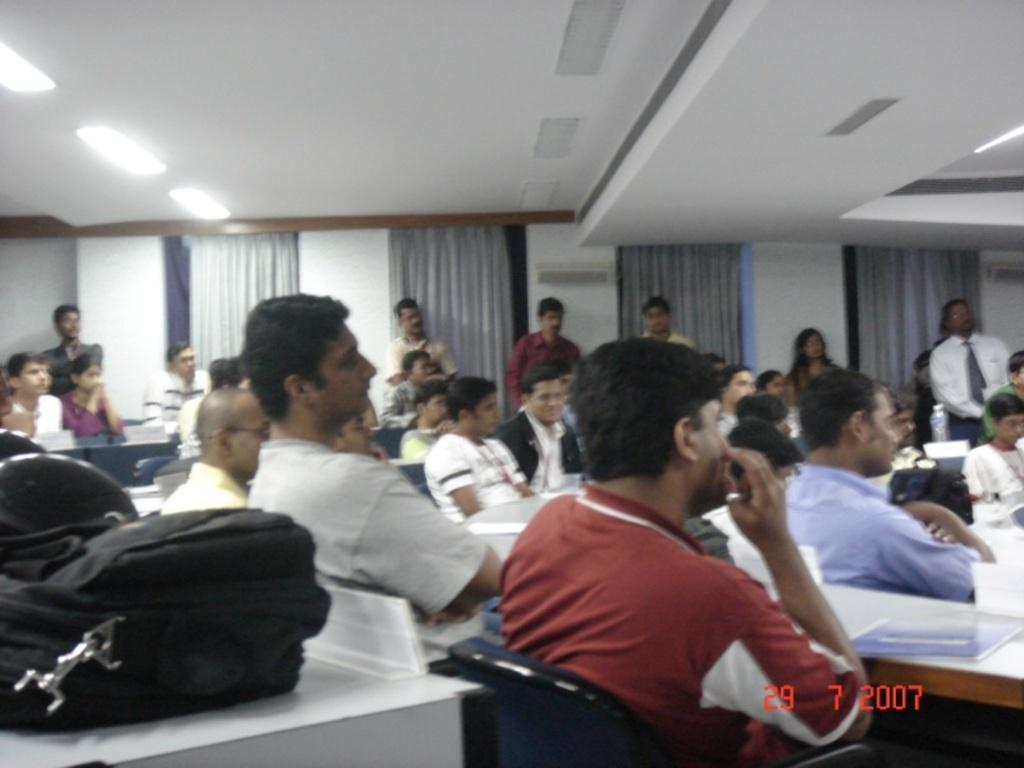What are the people in the image doing? The persons in the image are sitting on chairs. Can you describe the background of the image? In the background of the image, there are persons visible, as well as curtains, windows, and a wall. What might be used to cover the windows in the image? The curtains in the background of the image might be used to cover the windows. What type of prison can be seen in the image? There is no prison present in the image. How many rings are visible on the persons' fingers in the image? There is no information about rings or fingers in the image. 